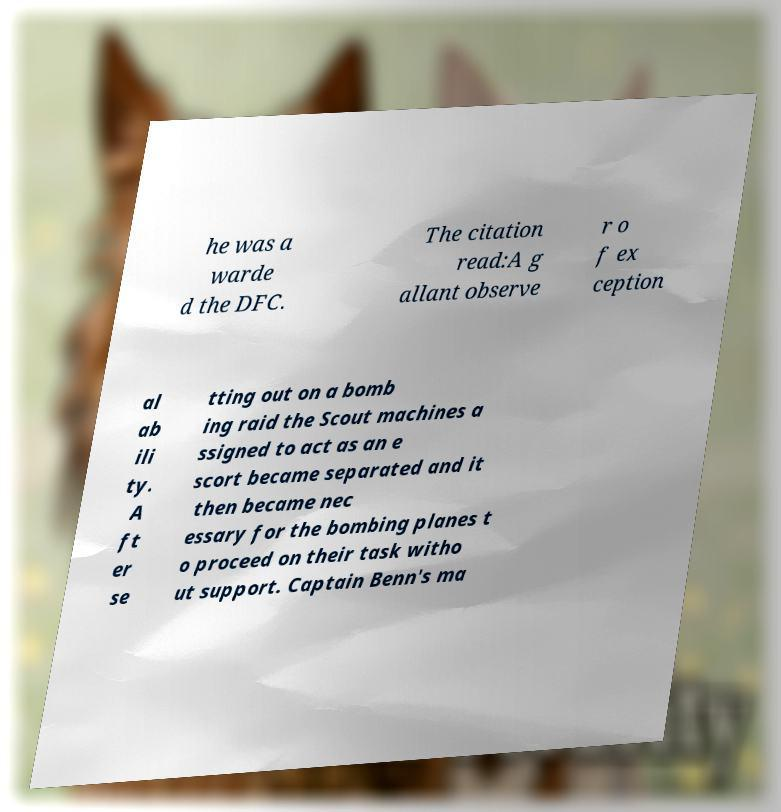Can you accurately transcribe the text from the provided image for me? he was a warde d the DFC. The citation read:A g allant observe r o f ex ception al ab ili ty. A ft er se tting out on a bomb ing raid the Scout machines a ssigned to act as an e scort became separated and it then became nec essary for the bombing planes t o proceed on their task witho ut support. Captain Benn's ma 